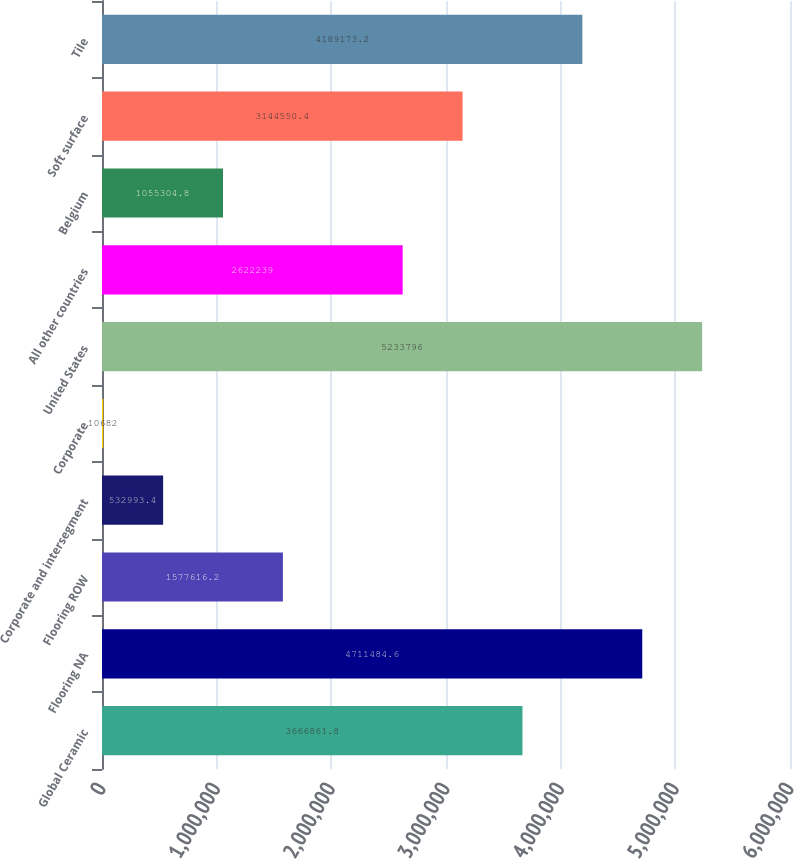Convert chart. <chart><loc_0><loc_0><loc_500><loc_500><bar_chart><fcel>Global Ceramic<fcel>Flooring NA<fcel>Flooring ROW<fcel>Corporate and intersegment<fcel>Corporate<fcel>United States<fcel>All other countries<fcel>Belgium<fcel>Soft surface<fcel>Tile<nl><fcel>3.66686e+06<fcel>4.71148e+06<fcel>1.57762e+06<fcel>532993<fcel>10682<fcel>5.2338e+06<fcel>2.62224e+06<fcel>1.0553e+06<fcel>3.14455e+06<fcel>4.18917e+06<nl></chart> 